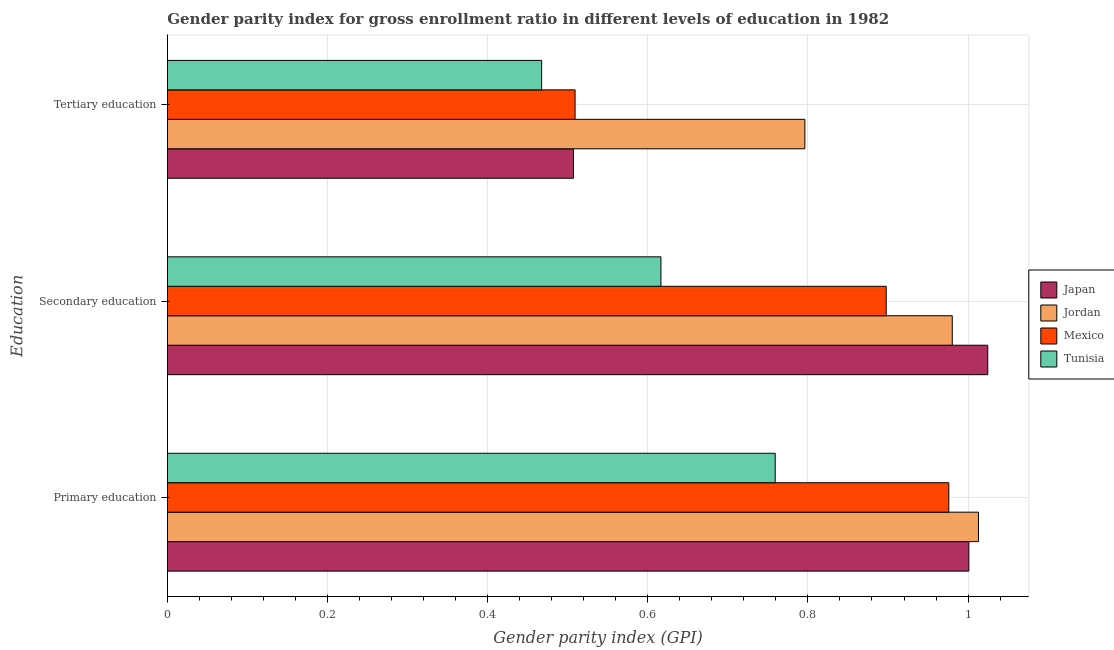How many different coloured bars are there?
Provide a short and direct response. 4. How many groups of bars are there?
Give a very brief answer. 3. Are the number of bars on each tick of the Y-axis equal?
Keep it short and to the point. Yes. What is the label of the 2nd group of bars from the top?
Keep it short and to the point. Secondary education. What is the gender parity index in primary education in Tunisia?
Give a very brief answer. 0.76. Across all countries, what is the maximum gender parity index in tertiary education?
Offer a terse response. 0.8. Across all countries, what is the minimum gender parity index in secondary education?
Make the answer very short. 0.62. In which country was the gender parity index in secondary education maximum?
Provide a short and direct response. Japan. In which country was the gender parity index in secondary education minimum?
Make the answer very short. Tunisia. What is the total gender parity index in secondary education in the graph?
Your answer should be very brief. 3.52. What is the difference between the gender parity index in tertiary education in Japan and that in Tunisia?
Ensure brevity in your answer.  0.04. What is the difference between the gender parity index in primary education in Japan and the gender parity index in tertiary education in Mexico?
Offer a terse response. 0.49. What is the average gender parity index in tertiary education per country?
Keep it short and to the point. 0.57. What is the difference between the gender parity index in primary education and gender parity index in tertiary education in Mexico?
Keep it short and to the point. 0.47. What is the ratio of the gender parity index in secondary education in Tunisia to that in Mexico?
Make the answer very short. 0.69. Is the difference between the gender parity index in primary education in Tunisia and Japan greater than the difference between the gender parity index in tertiary education in Tunisia and Japan?
Give a very brief answer. No. What is the difference between the highest and the second highest gender parity index in secondary education?
Your answer should be compact. 0.04. What is the difference between the highest and the lowest gender parity index in primary education?
Make the answer very short. 0.25. Is it the case that in every country, the sum of the gender parity index in primary education and gender parity index in secondary education is greater than the gender parity index in tertiary education?
Make the answer very short. Yes. How many countries are there in the graph?
Provide a succinct answer. 4. What is the difference between two consecutive major ticks on the X-axis?
Ensure brevity in your answer.  0.2. Are the values on the major ticks of X-axis written in scientific E-notation?
Offer a very short reply. No. Does the graph contain any zero values?
Offer a very short reply. No. Does the graph contain grids?
Your answer should be compact. Yes. How many legend labels are there?
Your answer should be very brief. 4. How are the legend labels stacked?
Make the answer very short. Vertical. What is the title of the graph?
Provide a succinct answer. Gender parity index for gross enrollment ratio in different levels of education in 1982. Does "Mozambique" appear as one of the legend labels in the graph?
Give a very brief answer. No. What is the label or title of the X-axis?
Offer a terse response. Gender parity index (GPI). What is the label or title of the Y-axis?
Provide a succinct answer. Education. What is the Gender parity index (GPI) in Japan in Primary education?
Provide a succinct answer. 1. What is the Gender parity index (GPI) in Jordan in Primary education?
Your answer should be very brief. 1.01. What is the Gender parity index (GPI) of Mexico in Primary education?
Ensure brevity in your answer.  0.98. What is the Gender parity index (GPI) in Tunisia in Primary education?
Ensure brevity in your answer.  0.76. What is the Gender parity index (GPI) of Japan in Secondary education?
Give a very brief answer. 1.02. What is the Gender parity index (GPI) in Jordan in Secondary education?
Give a very brief answer. 0.98. What is the Gender parity index (GPI) of Mexico in Secondary education?
Offer a terse response. 0.9. What is the Gender parity index (GPI) in Tunisia in Secondary education?
Offer a terse response. 0.62. What is the Gender parity index (GPI) in Japan in Tertiary education?
Ensure brevity in your answer.  0.51. What is the Gender parity index (GPI) of Jordan in Tertiary education?
Make the answer very short. 0.8. What is the Gender parity index (GPI) of Mexico in Tertiary education?
Provide a succinct answer. 0.51. What is the Gender parity index (GPI) of Tunisia in Tertiary education?
Your answer should be compact. 0.47. Across all Education, what is the maximum Gender parity index (GPI) in Japan?
Make the answer very short. 1.02. Across all Education, what is the maximum Gender parity index (GPI) in Jordan?
Ensure brevity in your answer.  1.01. Across all Education, what is the maximum Gender parity index (GPI) in Mexico?
Keep it short and to the point. 0.98. Across all Education, what is the maximum Gender parity index (GPI) of Tunisia?
Make the answer very short. 0.76. Across all Education, what is the minimum Gender parity index (GPI) of Japan?
Offer a very short reply. 0.51. Across all Education, what is the minimum Gender parity index (GPI) of Jordan?
Give a very brief answer. 0.8. Across all Education, what is the minimum Gender parity index (GPI) of Mexico?
Provide a short and direct response. 0.51. Across all Education, what is the minimum Gender parity index (GPI) in Tunisia?
Your answer should be very brief. 0.47. What is the total Gender parity index (GPI) of Japan in the graph?
Offer a very short reply. 2.53. What is the total Gender parity index (GPI) in Jordan in the graph?
Keep it short and to the point. 2.79. What is the total Gender parity index (GPI) in Mexico in the graph?
Your response must be concise. 2.38. What is the total Gender parity index (GPI) in Tunisia in the graph?
Offer a terse response. 1.84. What is the difference between the Gender parity index (GPI) of Japan in Primary education and that in Secondary education?
Your answer should be very brief. -0.02. What is the difference between the Gender parity index (GPI) of Jordan in Primary education and that in Secondary education?
Your answer should be compact. 0.03. What is the difference between the Gender parity index (GPI) of Mexico in Primary education and that in Secondary education?
Keep it short and to the point. 0.08. What is the difference between the Gender parity index (GPI) in Tunisia in Primary education and that in Secondary education?
Give a very brief answer. 0.14. What is the difference between the Gender parity index (GPI) in Japan in Primary education and that in Tertiary education?
Offer a very short reply. 0.49. What is the difference between the Gender parity index (GPI) in Jordan in Primary education and that in Tertiary education?
Give a very brief answer. 0.22. What is the difference between the Gender parity index (GPI) in Mexico in Primary education and that in Tertiary education?
Your answer should be compact. 0.47. What is the difference between the Gender parity index (GPI) in Tunisia in Primary education and that in Tertiary education?
Provide a succinct answer. 0.29. What is the difference between the Gender parity index (GPI) in Japan in Secondary education and that in Tertiary education?
Offer a terse response. 0.52. What is the difference between the Gender parity index (GPI) of Jordan in Secondary education and that in Tertiary education?
Provide a short and direct response. 0.18. What is the difference between the Gender parity index (GPI) in Mexico in Secondary education and that in Tertiary education?
Your response must be concise. 0.39. What is the difference between the Gender parity index (GPI) of Tunisia in Secondary education and that in Tertiary education?
Your answer should be compact. 0.15. What is the difference between the Gender parity index (GPI) in Japan in Primary education and the Gender parity index (GPI) in Jordan in Secondary education?
Give a very brief answer. 0.02. What is the difference between the Gender parity index (GPI) of Japan in Primary education and the Gender parity index (GPI) of Mexico in Secondary education?
Your answer should be compact. 0.1. What is the difference between the Gender parity index (GPI) of Japan in Primary education and the Gender parity index (GPI) of Tunisia in Secondary education?
Your response must be concise. 0.38. What is the difference between the Gender parity index (GPI) in Jordan in Primary education and the Gender parity index (GPI) in Mexico in Secondary education?
Your response must be concise. 0.12. What is the difference between the Gender parity index (GPI) in Jordan in Primary education and the Gender parity index (GPI) in Tunisia in Secondary education?
Your answer should be very brief. 0.4. What is the difference between the Gender parity index (GPI) of Mexico in Primary education and the Gender parity index (GPI) of Tunisia in Secondary education?
Offer a very short reply. 0.36. What is the difference between the Gender parity index (GPI) in Japan in Primary education and the Gender parity index (GPI) in Jordan in Tertiary education?
Ensure brevity in your answer.  0.2. What is the difference between the Gender parity index (GPI) in Japan in Primary education and the Gender parity index (GPI) in Mexico in Tertiary education?
Your response must be concise. 0.49. What is the difference between the Gender parity index (GPI) of Japan in Primary education and the Gender parity index (GPI) of Tunisia in Tertiary education?
Provide a succinct answer. 0.53. What is the difference between the Gender parity index (GPI) of Jordan in Primary education and the Gender parity index (GPI) of Mexico in Tertiary education?
Your answer should be very brief. 0.5. What is the difference between the Gender parity index (GPI) in Jordan in Primary education and the Gender parity index (GPI) in Tunisia in Tertiary education?
Offer a terse response. 0.55. What is the difference between the Gender parity index (GPI) in Mexico in Primary education and the Gender parity index (GPI) in Tunisia in Tertiary education?
Ensure brevity in your answer.  0.51. What is the difference between the Gender parity index (GPI) of Japan in Secondary education and the Gender parity index (GPI) of Jordan in Tertiary education?
Provide a succinct answer. 0.23. What is the difference between the Gender parity index (GPI) of Japan in Secondary education and the Gender parity index (GPI) of Mexico in Tertiary education?
Your response must be concise. 0.52. What is the difference between the Gender parity index (GPI) of Japan in Secondary education and the Gender parity index (GPI) of Tunisia in Tertiary education?
Provide a short and direct response. 0.56. What is the difference between the Gender parity index (GPI) in Jordan in Secondary education and the Gender parity index (GPI) in Mexico in Tertiary education?
Provide a short and direct response. 0.47. What is the difference between the Gender parity index (GPI) in Jordan in Secondary education and the Gender parity index (GPI) in Tunisia in Tertiary education?
Make the answer very short. 0.51. What is the difference between the Gender parity index (GPI) in Mexico in Secondary education and the Gender parity index (GPI) in Tunisia in Tertiary education?
Make the answer very short. 0.43. What is the average Gender parity index (GPI) in Japan per Education?
Offer a terse response. 0.84. What is the average Gender parity index (GPI) in Jordan per Education?
Your answer should be compact. 0.93. What is the average Gender parity index (GPI) in Mexico per Education?
Your answer should be compact. 0.79. What is the average Gender parity index (GPI) of Tunisia per Education?
Make the answer very short. 0.61. What is the difference between the Gender parity index (GPI) of Japan and Gender parity index (GPI) of Jordan in Primary education?
Your answer should be very brief. -0.01. What is the difference between the Gender parity index (GPI) in Japan and Gender parity index (GPI) in Mexico in Primary education?
Your answer should be very brief. 0.03. What is the difference between the Gender parity index (GPI) of Japan and Gender parity index (GPI) of Tunisia in Primary education?
Ensure brevity in your answer.  0.24. What is the difference between the Gender parity index (GPI) of Jordan and Gender parity index (GPI) of Mexico in Primary education?
Your answer should be compact. 0.04. What is the difference between the Gender parity index (GPI) of Jordan and Gender parity index (GPI) of Tunisia in Primary education?
Your response must be concise. 0.25. What is the difference between the Gender parity index (GPI) in Mexico and Gender parity index (GPI) in Tunisia in Primary education?
Provide a succinct answer. 0.22. What is the difference between the Gender parity index (GPI) of Japan and Gender parity index (GPI) of Jordan in Secondary education?
Provide a short and direct response. 0.04. What is the difference between the Gender parity index (GPI) of Japan and Gender parity index (GPI) of Mexico in Secondary education?
Offer a very short reply. 0.13. What is the difference between the Gender parity index (GPI) of Japan and Gender parity index (GPI) of Tunisia in Secondary education?
Your answer should be compact. 0.41. What is the difference between the Gender parity index (GPI) in Jordan and Gender parity index (GPI) in Mexico in Secondary education?
Offer a terse response. 0.08. What is the difference between the Gender parity index (GPI) of Jordan and Gender parity index (GPI) of Tunisia in Secondary education?
Ensure brevity in your answer.  0.36. What is the difference between the Gender parity index (GPI) in Mexico and Gender parity index (GPI) in Tunisia in Secondary education?
Make the answer very short. 0.28. What is the difference between the Gender parity index (GPI) in Japan and Gender parity index (GPI) in Jordan in Tertiary education?
Provide a short and direct response. -0.29. What is the difference between the Gender parity index (GPI) in Japan and Gender parity index (GPI) in Mexico in Tertiary education?
Make the answer very short. -0. What is the difference between the Gender parity index (GPI) of Japan and Gender parity index (GPI) of Tunisia in Tertiary education?
Make the answer very short. 0.04. What is the difference between the Gender parity index (GPI) of Jordan and Gender parity index (GPI) of Mexico in Tertiary education?
Make the answer very short. 0.29. What is the difference between the Gender parity index (GPI) in Jordan and Gender parity index (GPI) in Tunisia in Tertiary education?
Give a very brief answer. 0.33. What is the difference between the Gender parity index (GPI) of Mexico and Gender parity index (GPI) of Tunisia in Tertiary education?
Your answer should be very brief. 0.04. What is the ratio of the Gender parity index (GPI) of Jordan in Primary education to that in Secondary education?
Offer a terse response. 1.03. What is the ratio of the Gender parity index (GPI) of Mexico in Primary education to that in Secondary education?
Provide a succinct answer. 1.09. What is the ratio of the Gender parity index (GPI) of Tunisia in Primary education to that in Secondary education?
Your response must be concise. 1.23. What is the ratio of the Gender parity index (GPI) of Japan in Primary education to that in Tertiary education?
Ensure brevity in your answer.  1.97. What is the ratio of the Gender parity index (GPI) of Jordan in Primary education to that in Tertiary education?
Your answer should be very brief. 1.27. What is the ratio of the Gender parity index (GPI) in Mexico in Primary education to that in Tertiary education?
Offer a terse response. 1.92. What is the ratio of the Gender parity index (GPI) of Tunisia in Primary education to that in Tertiary education?
Provide a succinct answer. 1.62. What is the ratio of the Gender parity index (GPI) of Japan in Secondary education to that in Tertiary education?
Your answer should be compact. 2.02. What is the ratio of the Gender parity index (GPI) of Jordan in Secondary education to that in Tertiary education?
Offer a terse response. 1.23. What is the ratio of the Gender parity index (GPI) of Mexico in Secondary education to that in Tertiary education?
Offer a terse response. 1.76. What is the ratio of the Gender parity index (GPI) in Tunisia in Secondary education to that in Tertiary education?
Keep it short and to the point. 1.32. What is the difference between the highest and the second highest Gender parity index (GPI) in Japan?
Give a very brief answer. 0.02. What is the difference between the highest and the second highest Gender parity index (GPI) in Jordan?
Your answer should be compact. 0.03. What is the difference between the highest and the second highest Gender parity index (GPI) of Mexico?
Make the answer very short. 0.08. What is the difference between the highest and the second highest Gender parity index (GPI) of Tunisia?
Give a very brief answer. 0.14. What is the difference between the highest and the lowest Gender parity index (GPI) in Japan?
Provide a short and direct response. 0.52. What is the difference between the highest and the lowest Gender parity index (GPI) in Jordan?
Offer a terse response. 0.22. What is the difference between the highest and the lowest Gender parity index (GPI) in Mexico?
Offer a terse response. 0.47. What is the difference between the highest and the lowest Gender parity index (GPI) of Tunisia?
Offer a very short reply. 0.29. 